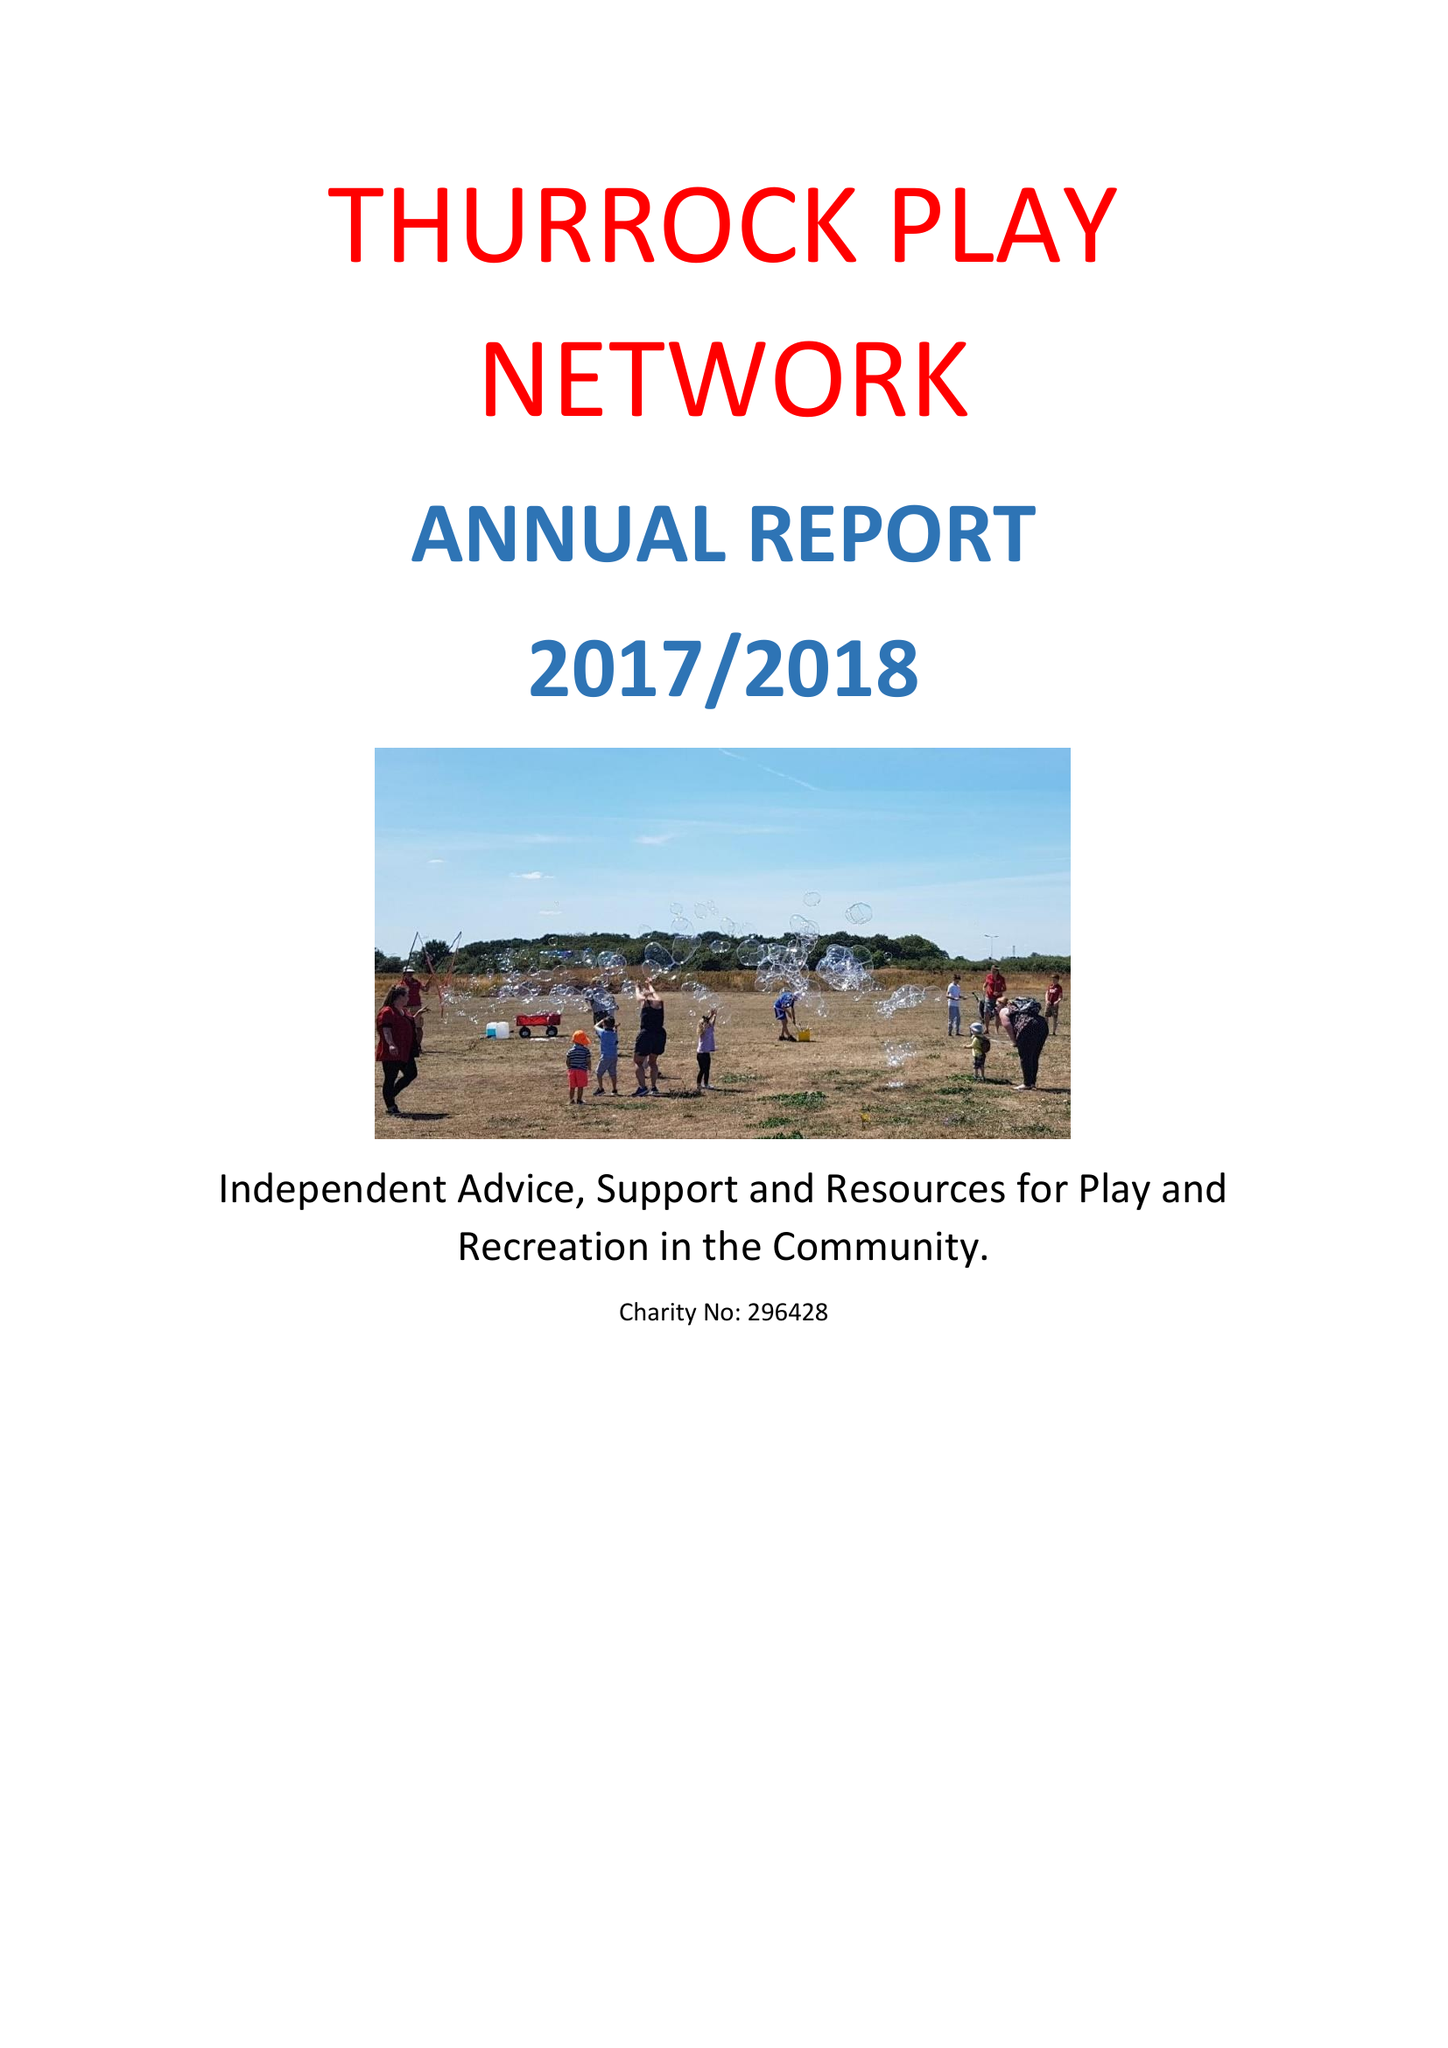What is the value for the address__postcode?
Answer the question using a single word or phrase. RM16 3AP 